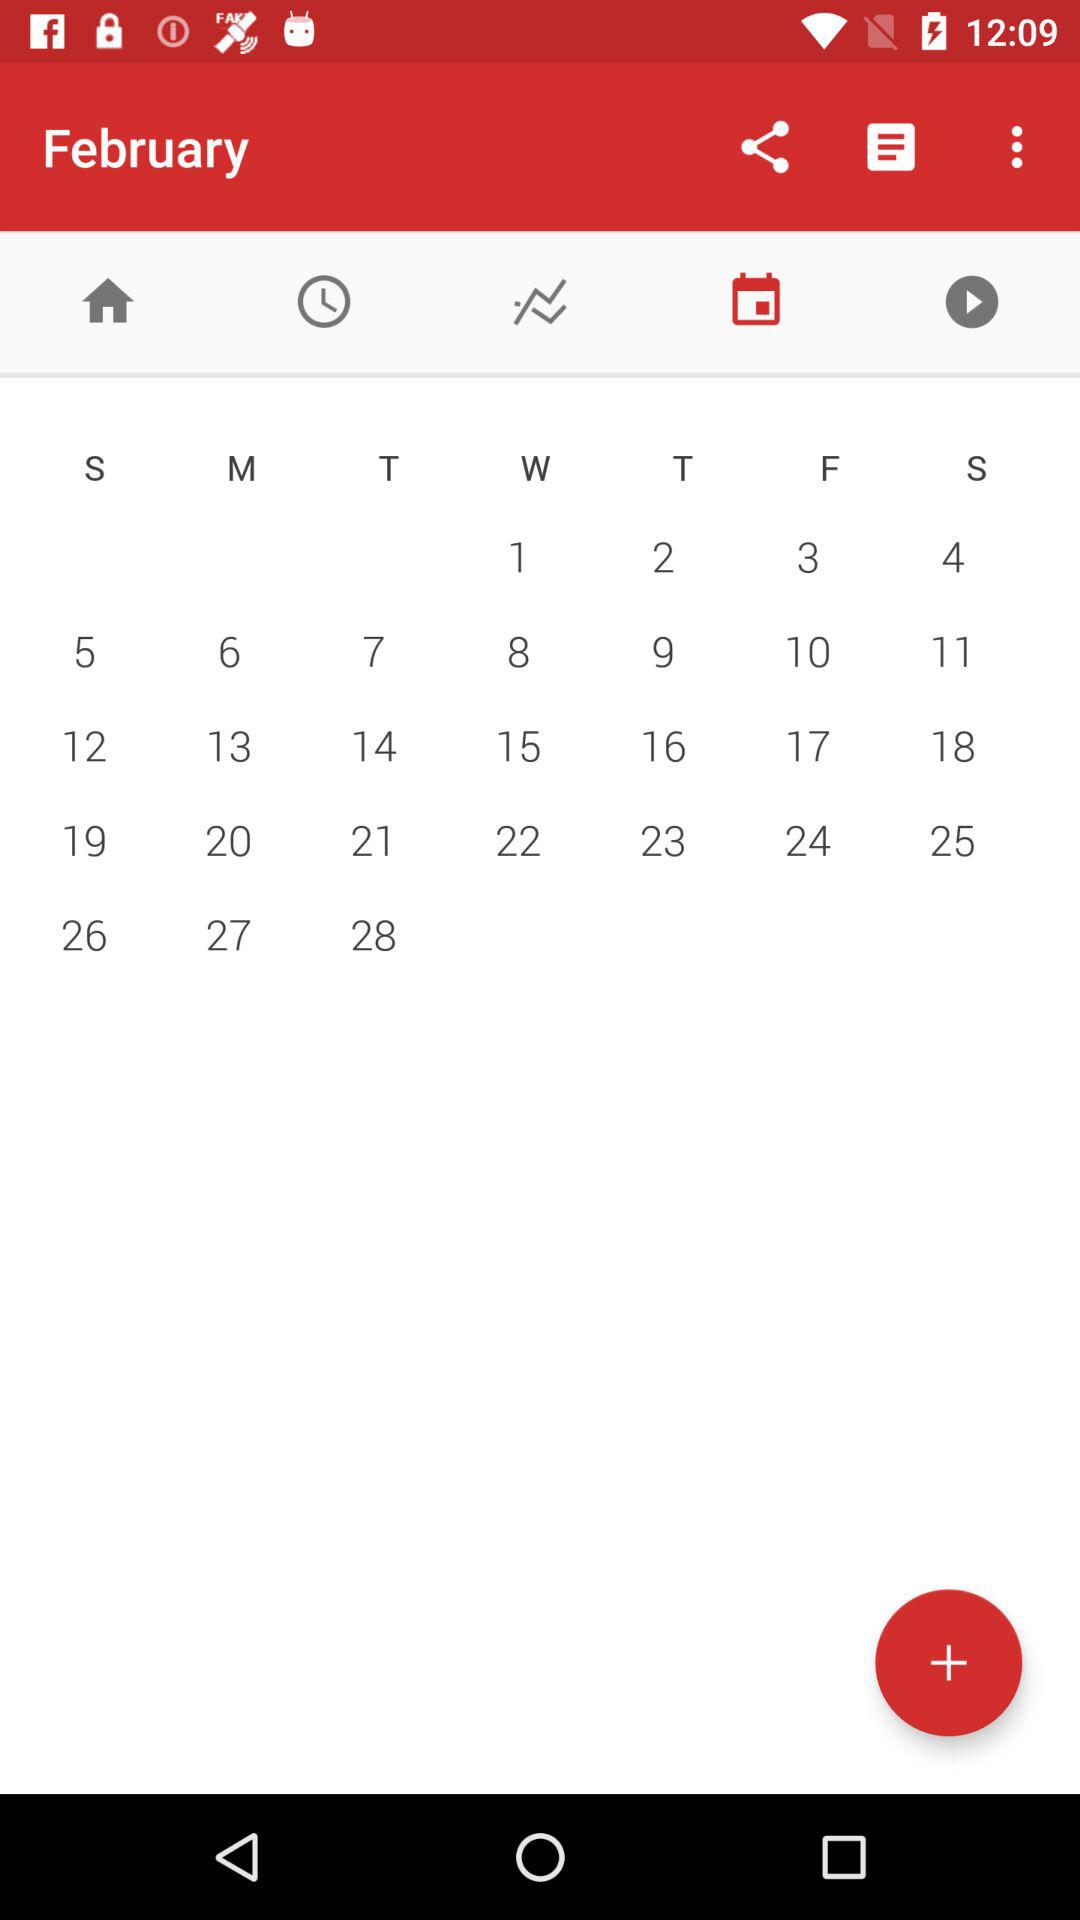Can we add an event?
When the provided information is insufficient, respond with <no answer>. <no answer> 